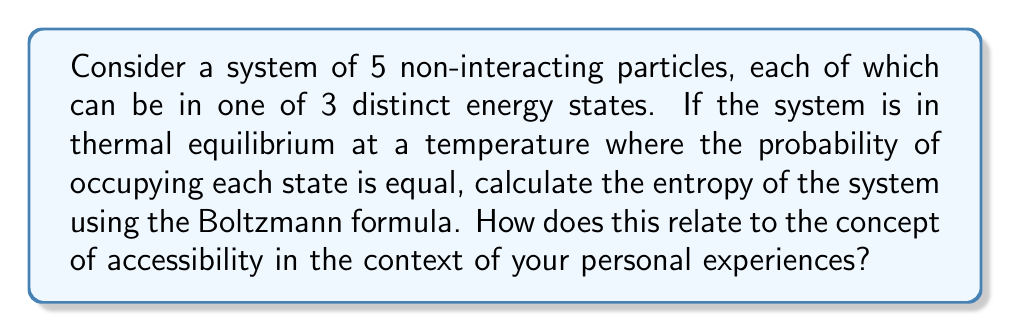Can you answer this question? Let's approach this step-by-step:

1) The Boltzmann formula for entropy is:

   $$S = k_B \ln W$$

   where $S$ is entropy, $k_B$ is Boltzmann's constant, and $W$ is the number of microstates.

2) In this system:
   - There are 5 particles
   - Each particle can be in 3 states
   - The probability of each state is equal

3) To find $W$, we need to calculate the total number of ways to arrange 5 particles in 3 states. This is equivalent to the number of ways to choose with replacement 5 times from 3 options. The formula for this is:

   $$W = 3^5 = 243$$

4) Now we can plug this into the Boltzmann formula:

   $$S = k_B \ln (243)$$

5) Simplifying:

   $$S = k_B \ln 243 \approx 5.49k_B$$

This result shows that the entropy is positive and finite, indicating that the system has a certain degree of disorder or unpredictability.

Relating this to the concept of accessibility in personal experiences:
Just as each particle in this system has equal probability to access any of the three states, creating a diverse range of possible configurations, individuals with disabilities often find unique ways to access and interact with their environment. This diversity of approaches and adaptations can be seen as a form of "entropy" in human experience, where creativity and resilience lead to a rich variety of life paths and solutions.
Answer: $$S = k_B \ln 243 \approx 5.49k_B$$ 